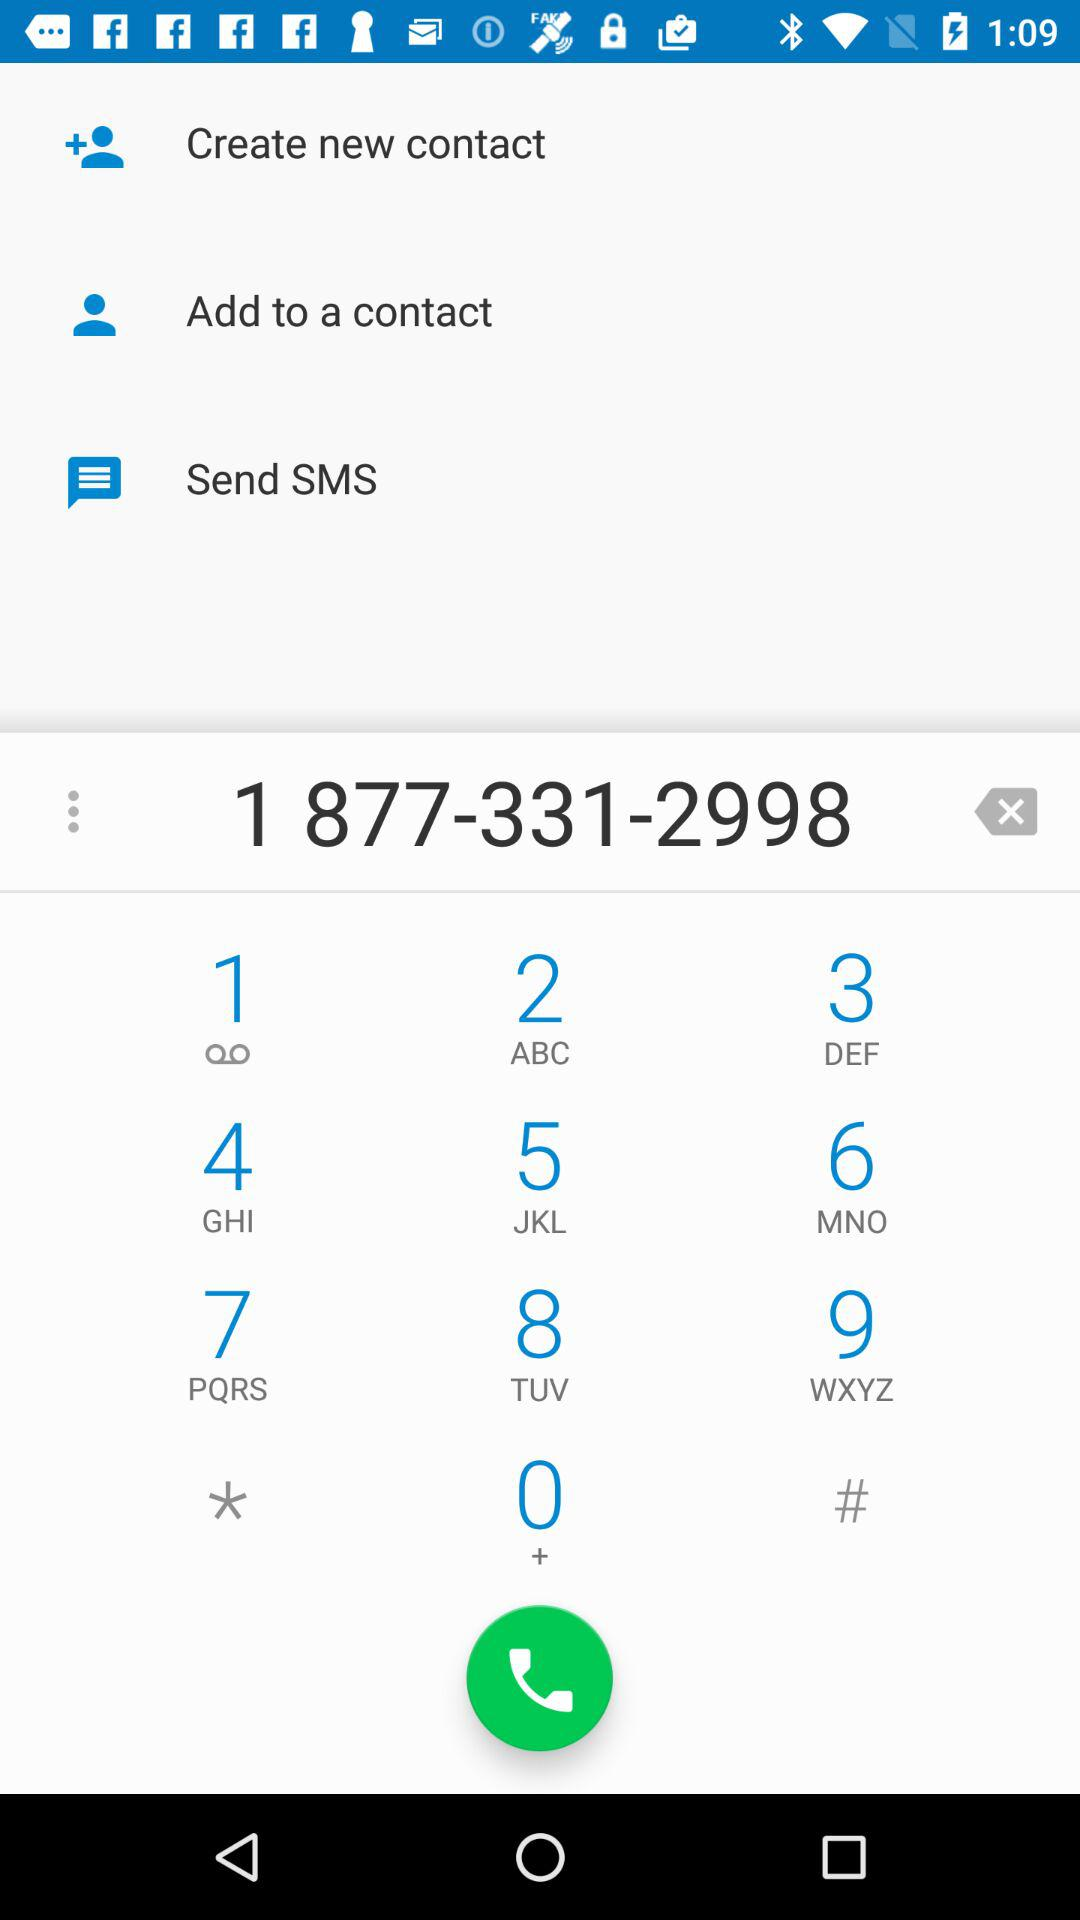How many action items are available?
Answer the question using a single word or phrase. 3 